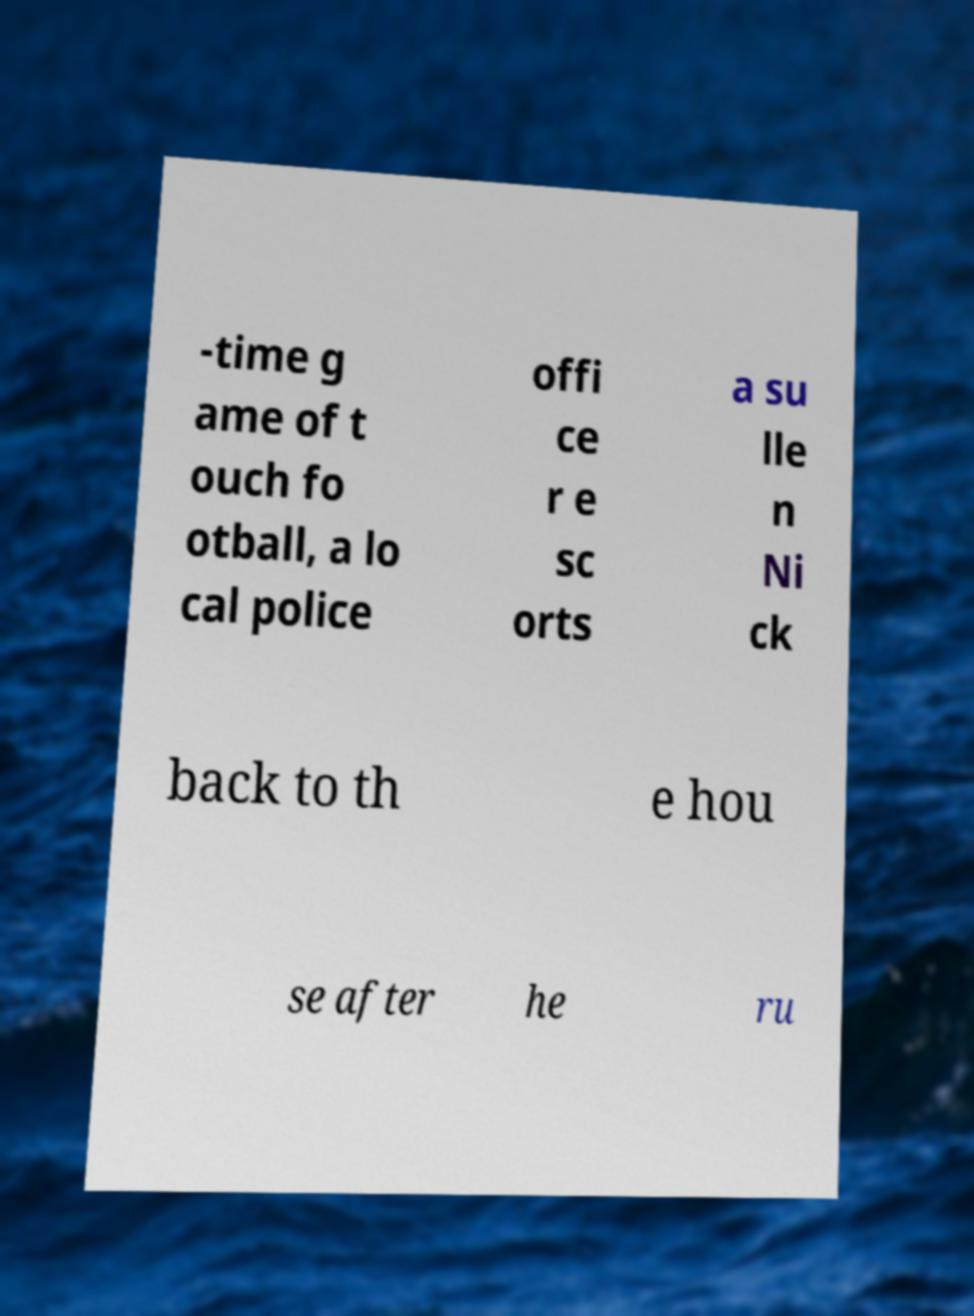Please identify and transcribe the text found in this image. -time g ame of t ouch fo otball, a lo cal police offi ce r e sc orts a su lle n Ni ck back to th e hou se after he ru 